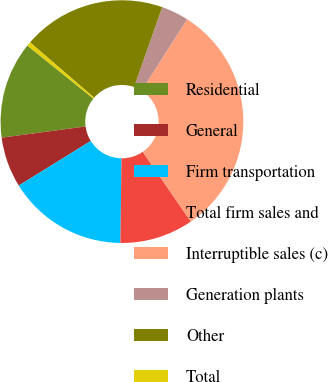<chart> <loc_0><loc_0><loc_500><loc_500><pie_chart><fcel>Residential<fcel>General<fcel>Firm transportation<fcel>Total firm sales and<fcel>Interruptible sales (c)<fcel>Generation plants<fcel>Other<fcel>Total<nl><fcel>12.89%<fcel>6.72%<fcel>15.97%<fcel>9.8%<fcel>31.38%<fcel>3.64%<fcel>19.05%<fcel>0.55%<nl></chart> 